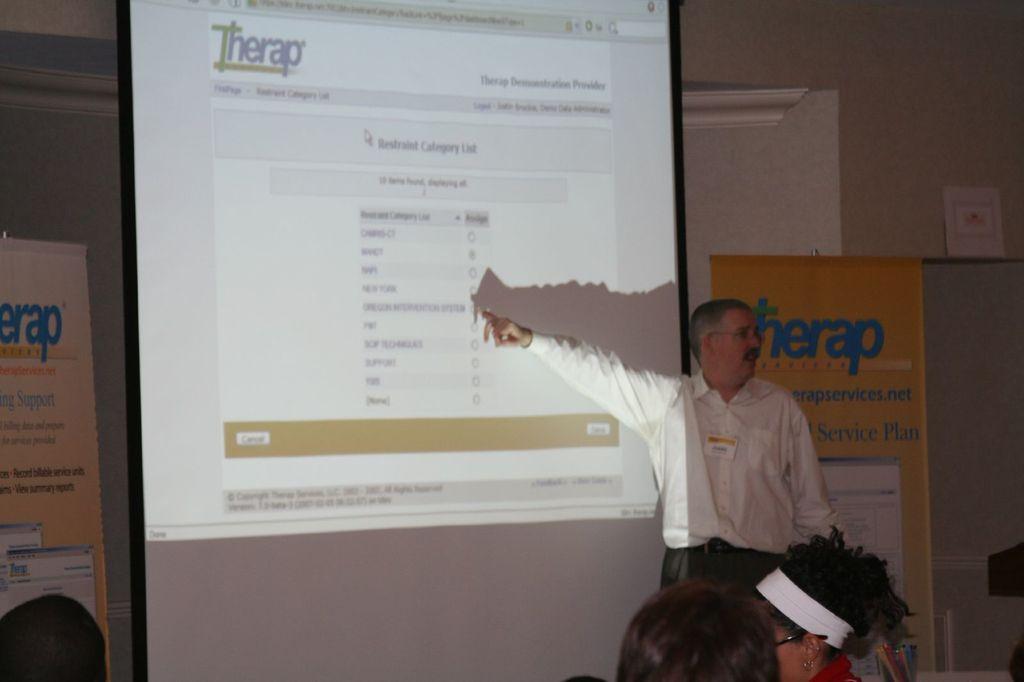Could you give a brief overview of what you see in this image? At the bottom of the image there are persons heads. To the right side of the image there is a person standing. In the background of the image there is projector screen, wall, banners. 